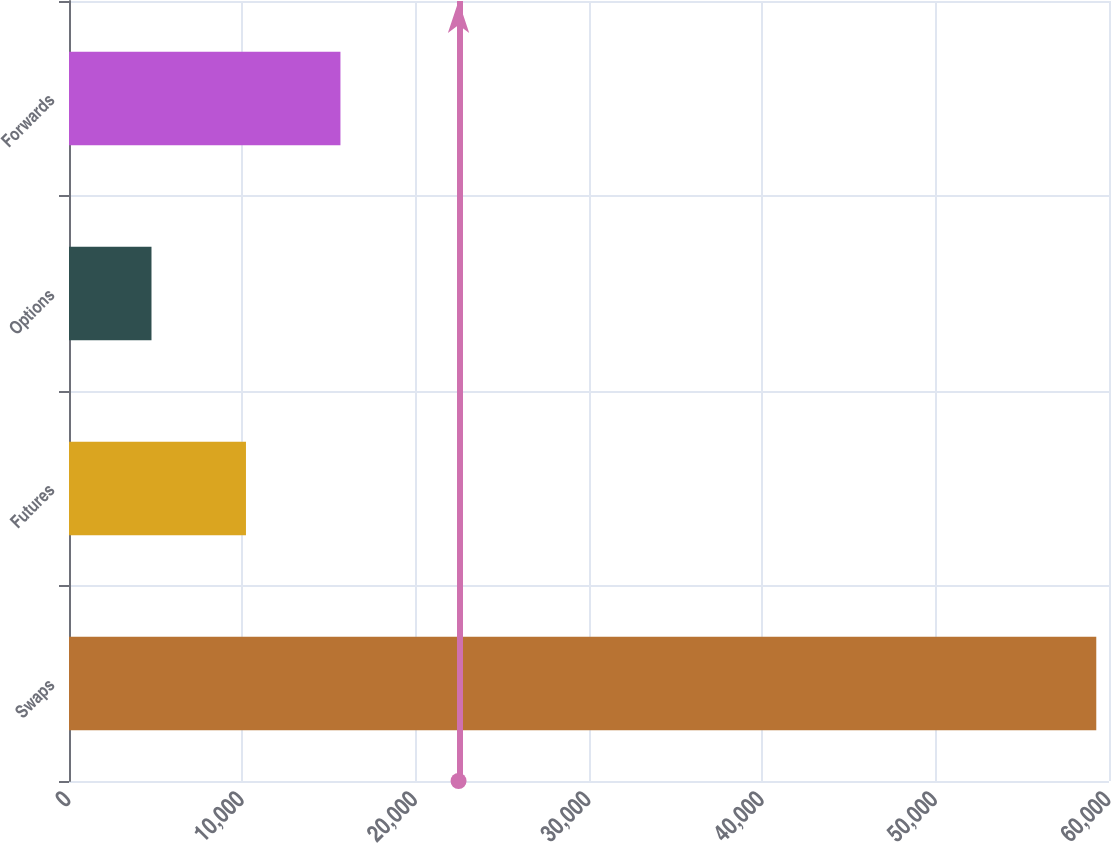Convert chart to OTSL. <chart><loc_0><loc_0><loc_500><loc_500><bar_chart><fcel>Swaps<fcel>Futures<fcel>Options<fcel>Forwards<nl><fcel>59266<fcel>10209.7<fcel>4759<fcel>15660.4<nl></chart> 